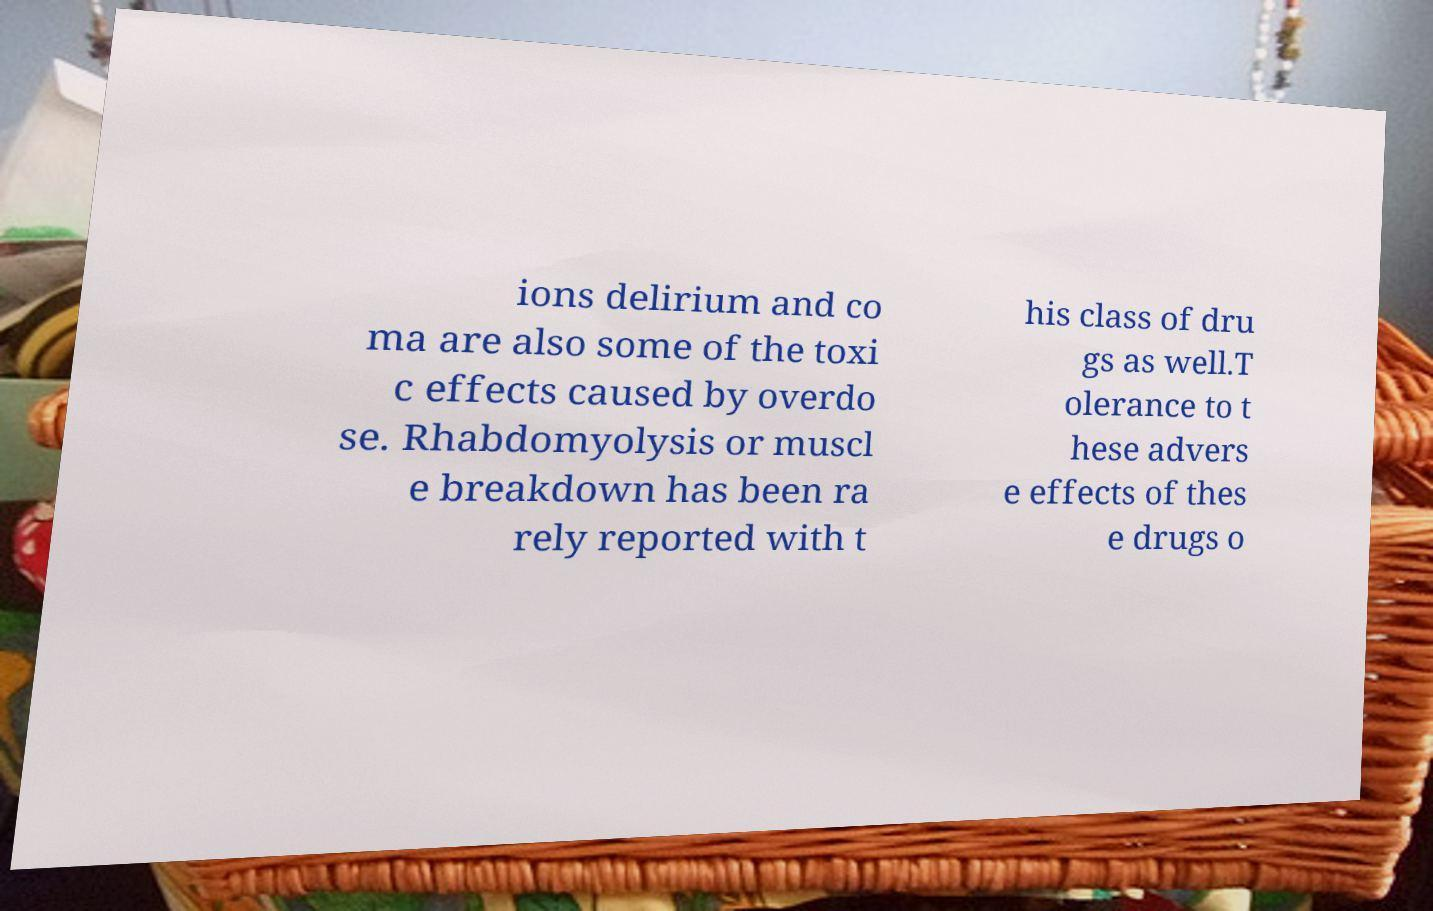What messages or text are displayed in this image? I need them in a readable, typed format. ions delirium and co ma are also some of the toxi c effects caused by overdo se. Rhabdomyolysis or muscl e breakdown has been ra rely reported with t his class of dru gs as well.T olerance to t hese advers e effects of thes e drugs o 